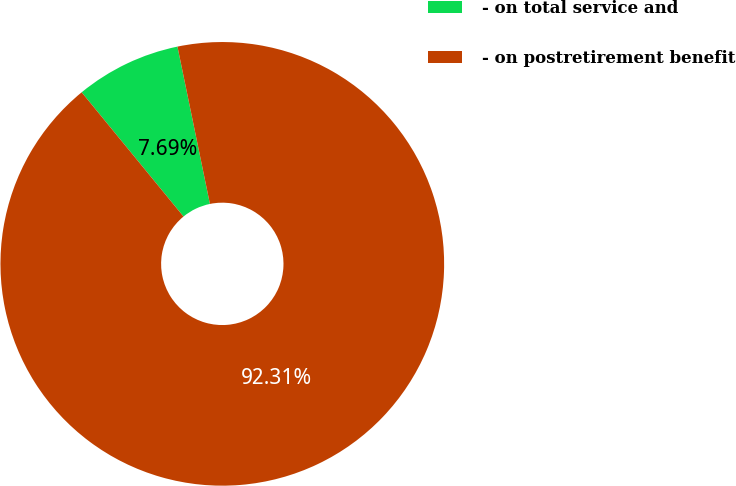Convert chart. <chart><loc_0><loc_0><loc_500><loc_500><pie_chart><fcel>- on total service and<fcel>- on postretirement benefit<nl><fcel>7.69%<fcel>92.31%<nl></chart> 